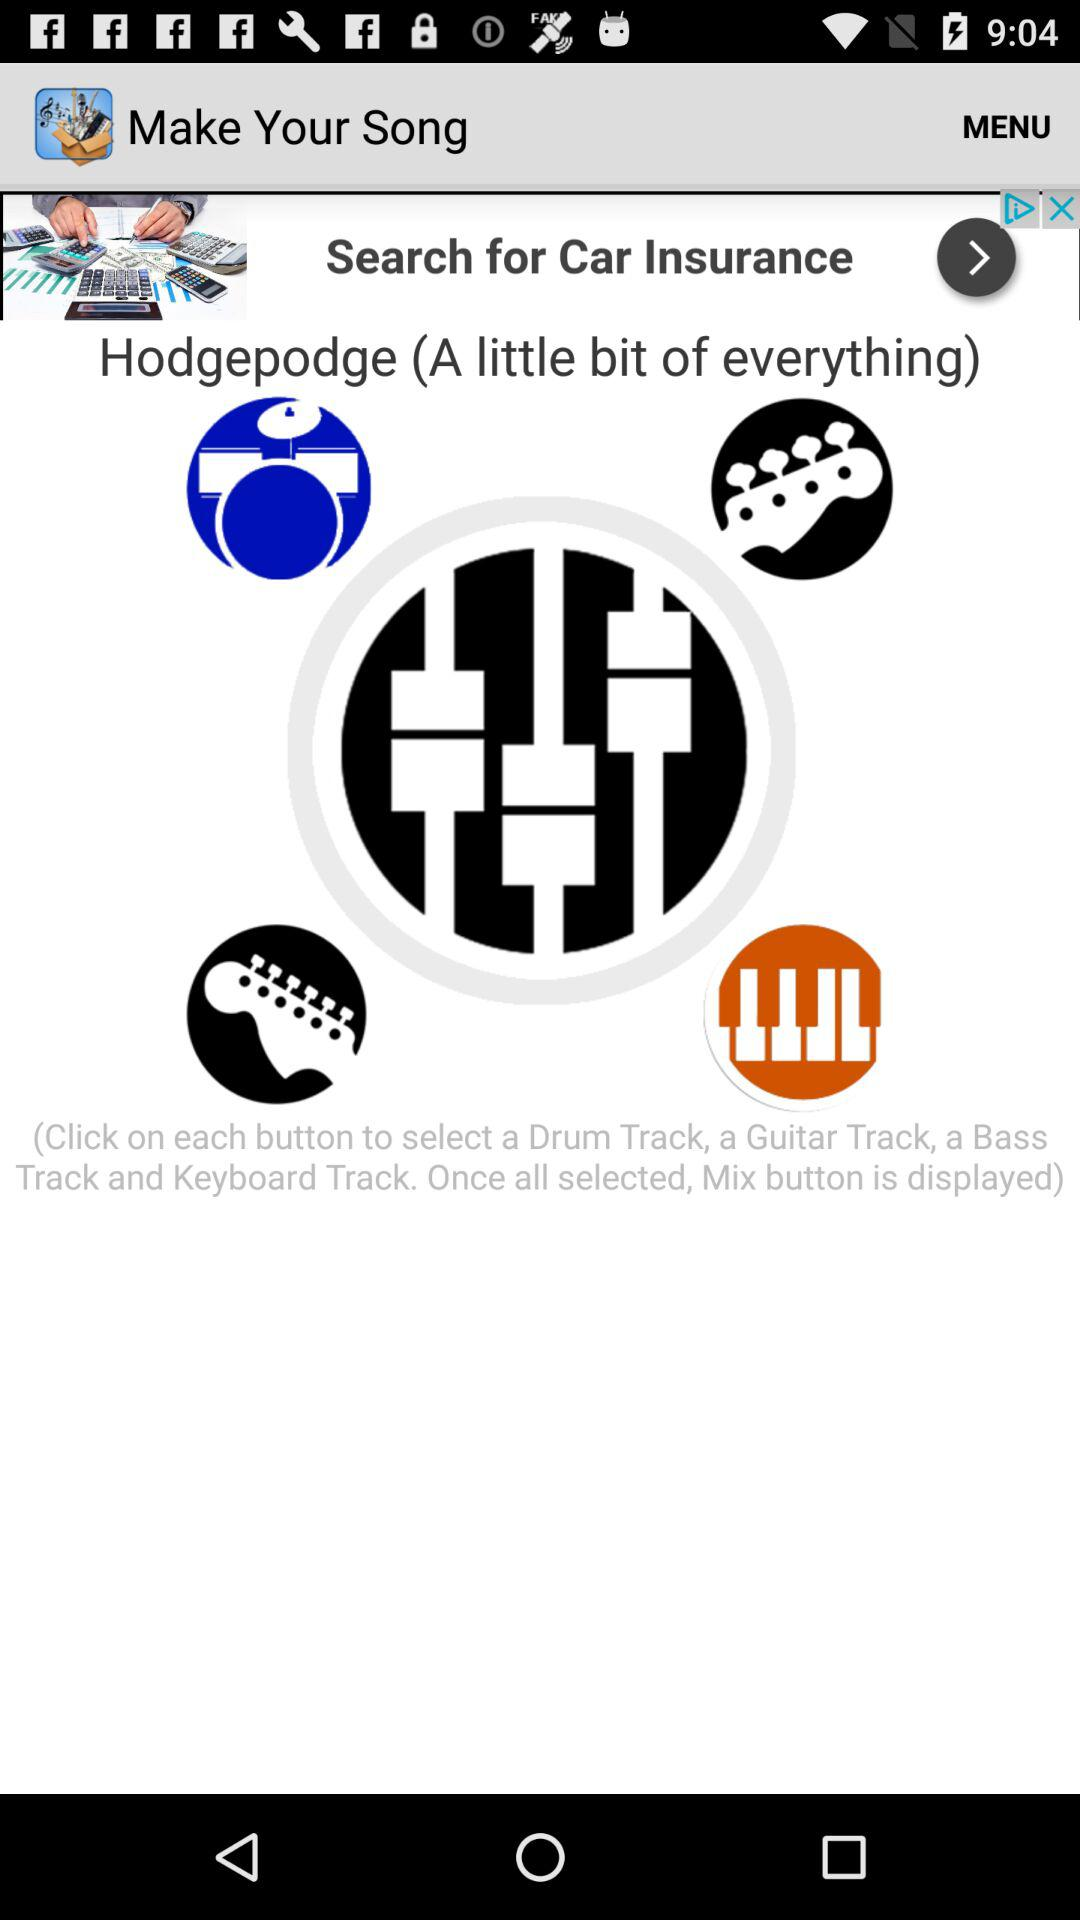What happens when all the buttons are selected? When all the buttons are selected, the mix button is displayed. 